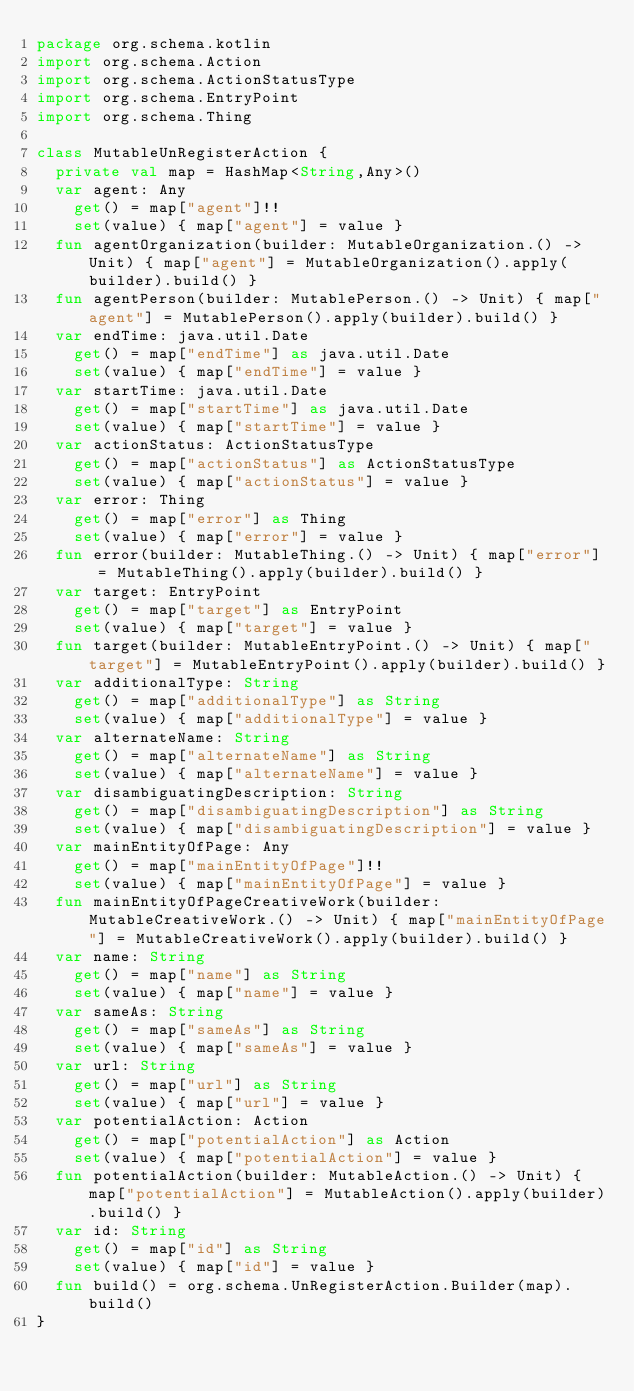Convert code to text. <code><loc_0><loc_0><loc_500><loc_500><_Kotlin_>package org.schema.kotlin
import org.schema.Action
import org.schema.ActionStatusType
import org.schema.EntryPoint
import org.schema.Thing

class MutableUnRegisterAction {
  private val map = HashMap<String,Any>()
  var agent: Any
    get() = map["agent"]!!
    set(value) { map["agent"] = value }
  fun agentOrganization(builder: MutableOrganization.() -> Unit) { map["agent"] = MutableOrganization().apply(builder).build() }
  fun agentPerson(builder: MutablePerson.() -> Unit) { map["agent"] = MutablePerson().apply(builder).build() }
  var endTime: java.util.Date
    get() = map["endTime"] as java.util.Date
    set(value) { map["endTime"] = value }
  var startTime: java.util.Date
    get() = map["startTime"] as java.util.Date
    set(value) { map["startTime"] = value }
  var actionStatus: ActionStatusType
    get() = map["actionStatus"] as ActionStatusType
    set(value) { map["actionStatus"] = value }
  var error: Thing
    get() = map["error"] as Thing
    set(value) { map["error"] = value }
  fun error(builder: MutableThing.() -> Unit) { map["error"] = MutableThing().apply(builder).build() }
  var target: EntryPoint
    get() = map["target"] as EntryPoint
    set(value) { map["target"] = value }
  fun target(builder: MutableEntryPoint.() -> Unit) { map["target"] = MutableEntryPoint().apply(builder).build() }
  var additionalType: String
    get() = map["additionalType"] as String
    set(value) { map["additionalType"] = value }
  var alternateName: String
    get() = map["alternateName"] as String
    set(value) { map["alternateName"] = value }
  var disambiguatingDescription: String
    get() = map["disambiguatingDescription"] as String
    set(value) { map["disambiguatingDescription"] = value }
  var mainEntityOfPage: Any
    get() = map["mainEntityOfPage"]!!
    set(value) { map["mainEntityOfPage"] = value }
  fun mainEntityOfPageCreativeWork(builder: MutableCreativeWork.() -> Unit) { map["mainEntityOfPage"] = MutableCreativeWork().apply(builder).build() }
  var name: String
    get() = map["name"] as String
    set(value) { map["name"] = value }
  var sameAs: String
    get() = map["sameAs"] as String
    set(value) { map["sameAs"] = value }
  var url: String
    get() = map["url"] as String
    set(value) { map["url"] = value }
  var potentialAction: Action
    get() = map["potentialAction"] as Action
    set(value) { map["potentialAction"] = value }
  fun potentialAction(builder: MutableAction.() -> Unit) { map["potentialAction"] = MutableAction().apply(builder).build() }
  var id: String
    get() = map["id"] as String
    set(value) { map["id"] = value }
  fun build() = org.schema.UnRegisterAction.Builder(map).build()
}
</code> 